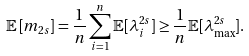Convert formula to latex. <formula><loc_0><loc_0><loc_500><loc_500>\mathbb { E } \left [ m _ { 2 s } \right ] = \frac { 1 } { n } \sum _ { i = 1 } ^ { n } \mathbb { E } [ \lambda _ { i } ^ { 2 s } ] \geq \frac { 1 } { n } \mathbb { E } [ \lambda _ { \max } ^ { 2 s } ] .</formula> 